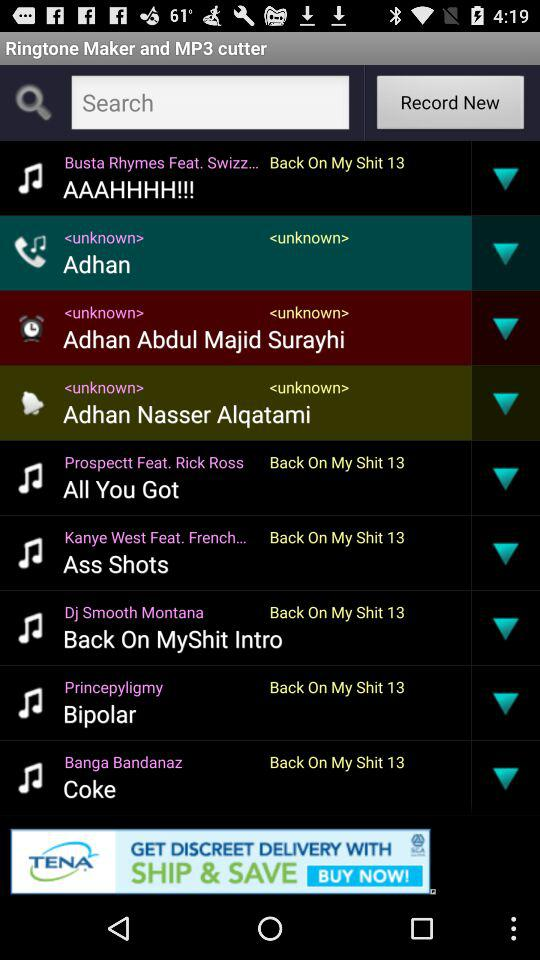Who sings "Ass Shots"? The "Ass Shots" is sung by "Kanye West Feat. French...". 